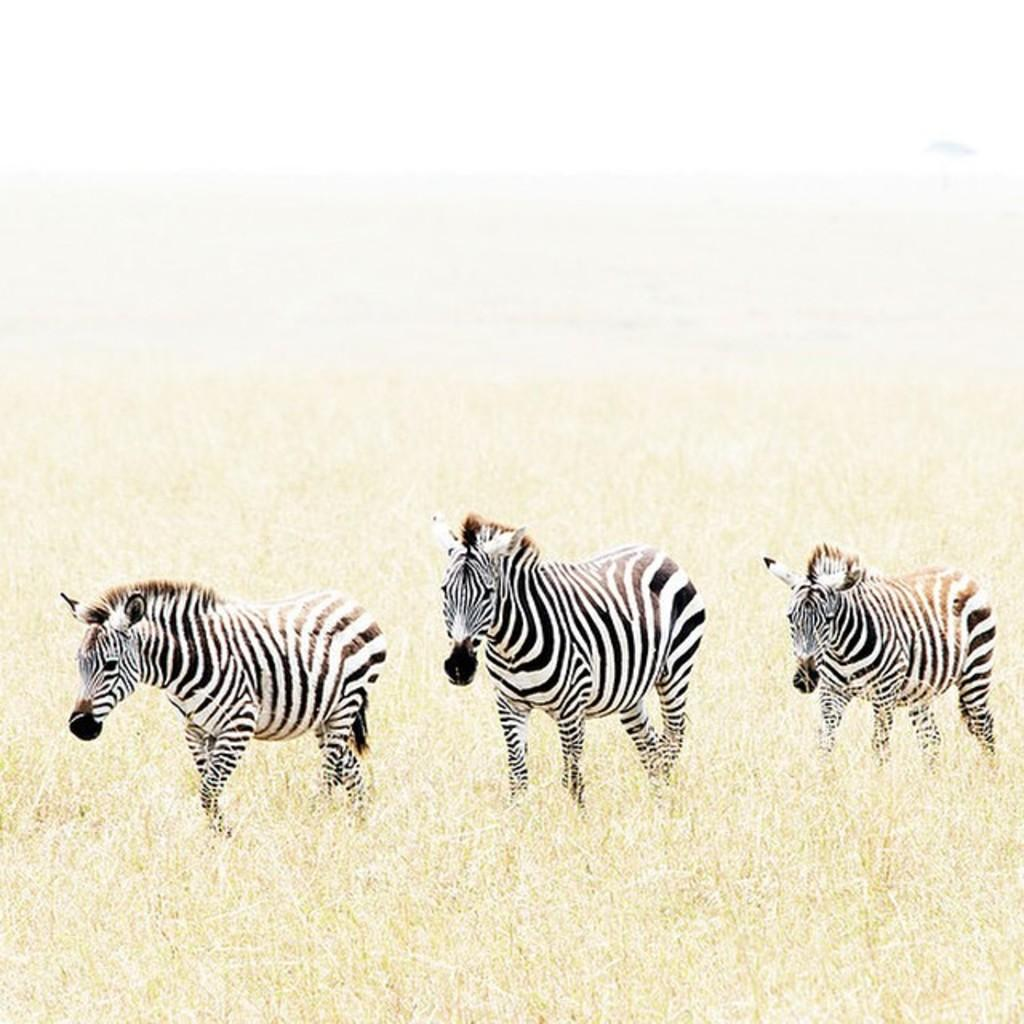How many zebras are present in the image? There are three zebras in the image. What is the location of the zebras in the image? The zebras are on the ground in the image. What type of vegetation can be seen on the ground in the image? There is grass on the ground in the image. What is visible at the top of the image? The sky is visible at the top of the image. What type of veil is being worn by the zebra in the image? There is no veil present in the image; the zebras are not wearing any clothing or accessories. 